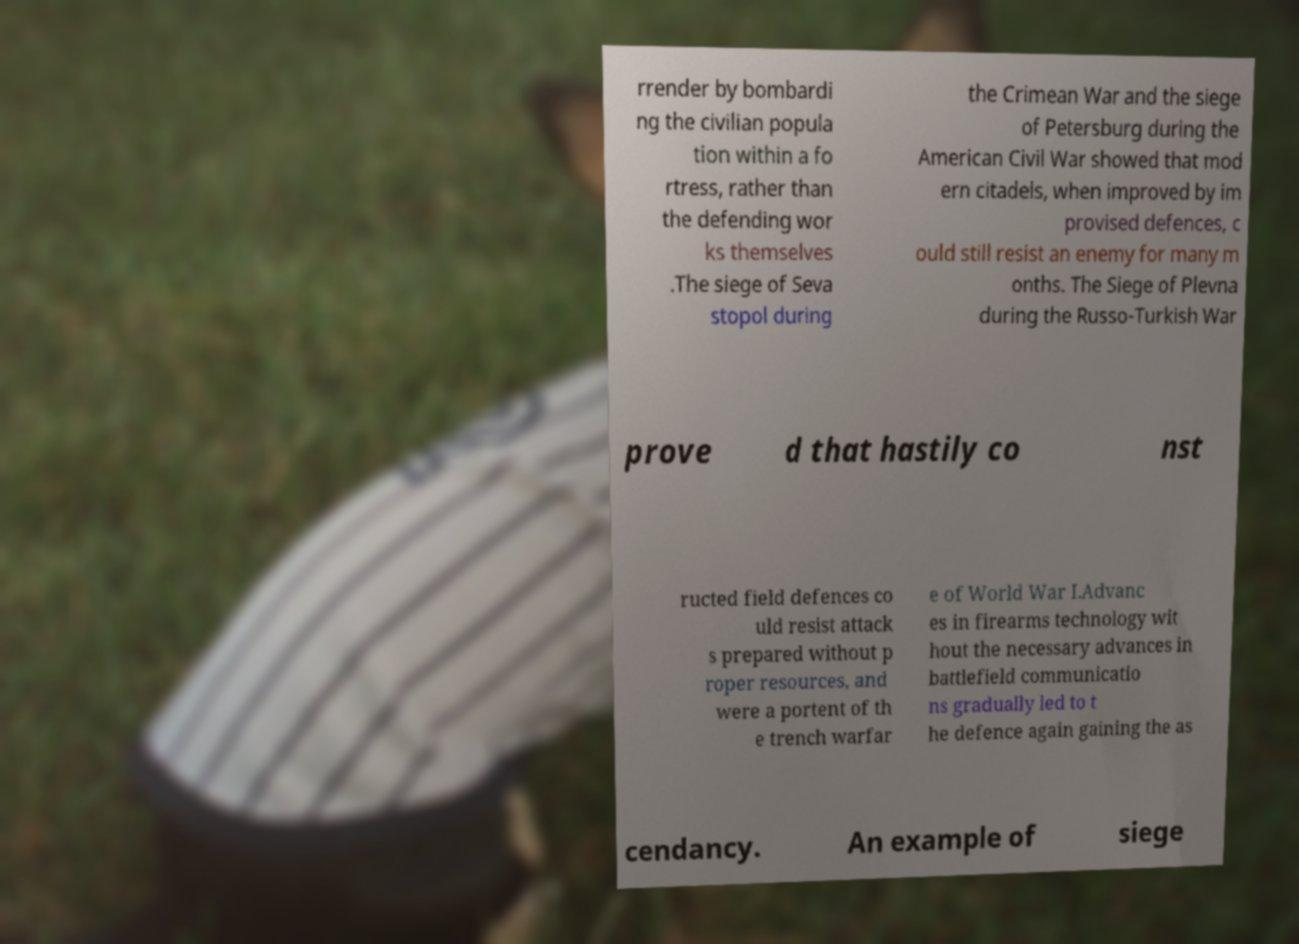There's text embedded in this image that I need extracted. Can you transcribe it verbatim? rrender by bombardi ng the civilian popula tion within a fo rtress, rather than the defending wor ks themselves .The siege of Seva stopol during the Crimean War and the siege of Petersburg during the American Civil War showed that mod ern citadels, when improved by im provised defences, c ould still resist an enemy for many m onths. The Siege of Plevna during the Russo-Turkish War prove d that hastily co nst ructed field defences co uld resist attack s prepared without p roper resources, and were a portent of th e trench warfar e of World War I.Advanc es in firearms technology wit hout the necessary advances in battlefield communicatio ns gradually led to t he defence again gaining the as cendancy. An example of siege 